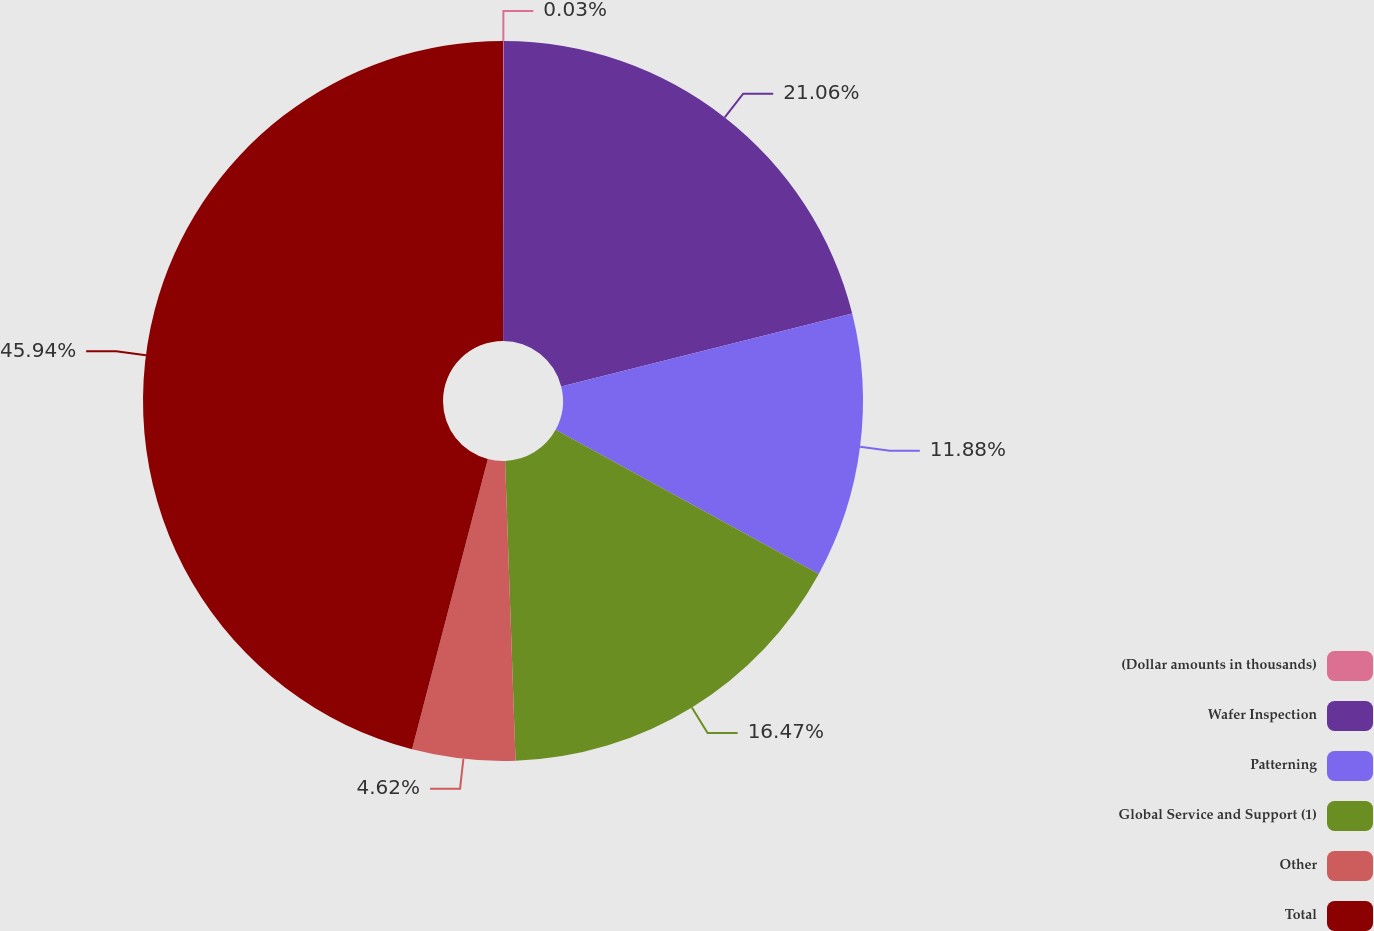Convert chart to OTSL. <chart><loc_0><loc_0><loc_500><loc_500><pie_chart><fcel>(Dollar amounts in thousands)<fcel>Wafer Inspection<fcel>Patterning<fcel>Global Service and Support (1)<fcel>Other<fcel>Total<nl><fcel>0.03%<fcel>21.06%<fcel>11.88%<fcel>16.47%<fcel>4.62%<fcel>45.93%<nl></chart> 